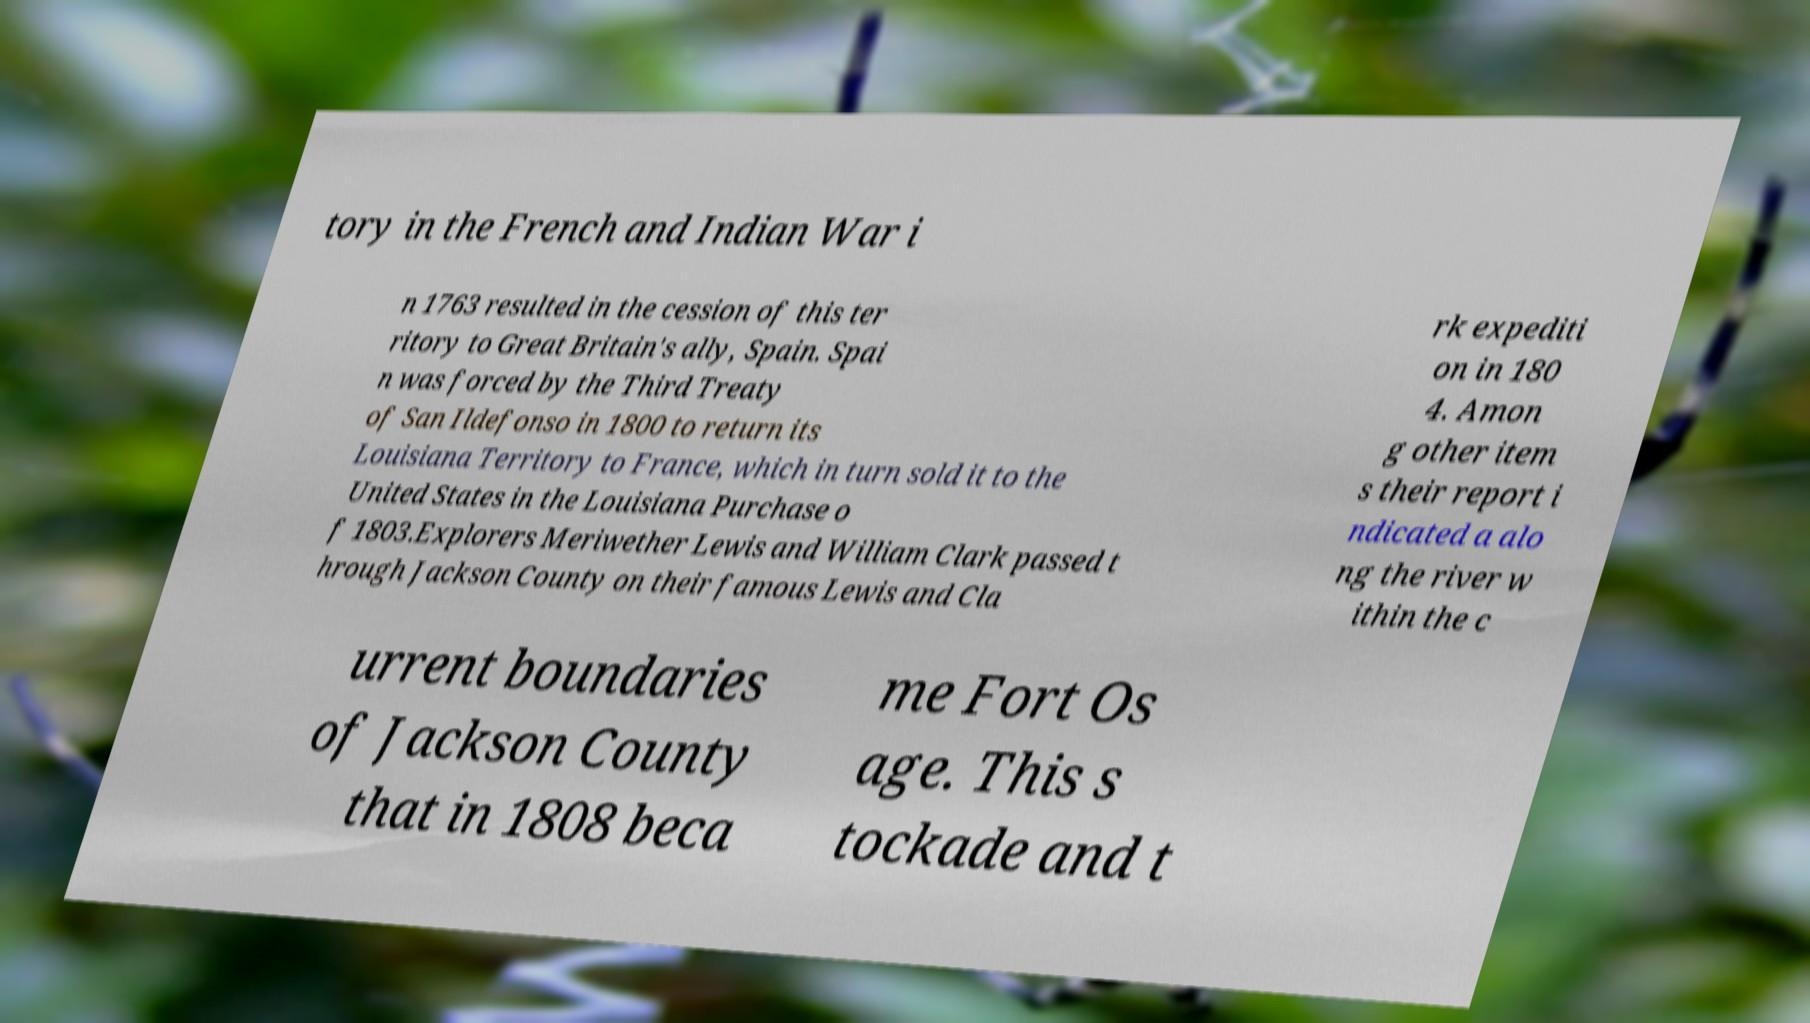I need the written content from this picture converted into text. Can you do that? tory in the French and Indian War i n 1763 resulted in the cession of this ter ritory to Great Britain's ally, Spain. Spai n was forced by the Third Treaty of San Ildefonso in 1800 to return its Louisiana Territory to France, which in turn sold it to the United States in the Louisiana Purchase o f 1803.Explorers Meriwether Lewis and William Clark passed t hrough Jackson County on their famous Lewis and Cla rk expediti on in 180 4. Amon g other item s their report i ndicated a alo ng the river w ithin the c urrent boundaries of Jackson County that in 1808 beca me Fort Os age. This s tockade and t 